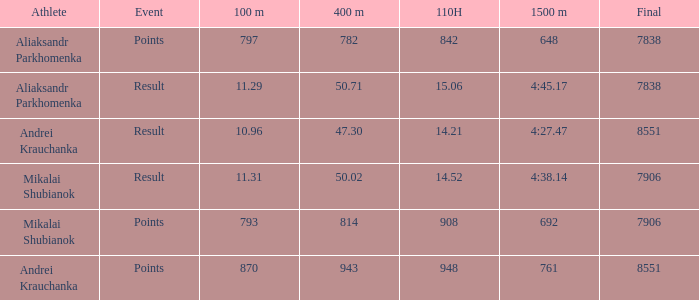What was the 110H that the 1500m was 692 and the final was more than 7906? 0.0. 